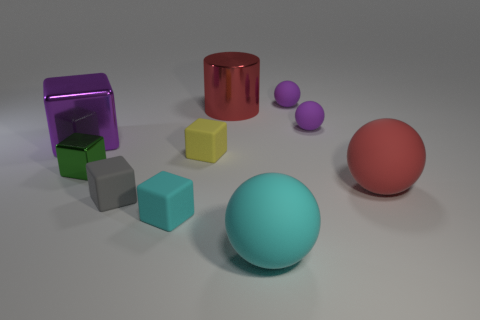Is there a big thing of the same color as the metal cylinder?
Your answer should be compact. Yes. Are there fewer small cyan objects on the left side of the green metal thing than small gray matte blocks that are in front of the tiny gray matte thing?
Make the answer very short. No. What is the block that is both to the left of the yellow thing and behind the tiny green object made of?
Provide a succinct answer. Metal. Does the small yellow rubber object have the same shape as the metallic object in front of the large purple thing?
Ensure brevity in your answer.  Yes. What number of other objects are the same size as the red sphere?
Offer a terse response. 3. Are there more gray blocks than tiny things?
Keep it short and to the point. No. What number of small objects are both in front of the yellow matte object and behind the big red rubber thing?
Your answer should be very brief. 1. There is a large rubber thing in front of the large red object in front of the big metal cylinder behind the purple metallic thing; what shape is it?
Give a very brief answer. Sphere. Is there any other thing that has the same shape as the red metallic object?
Give a very brief answer. No. What number of blocks are either rubber objects or big matte things?
Your response must be concise. 3. 